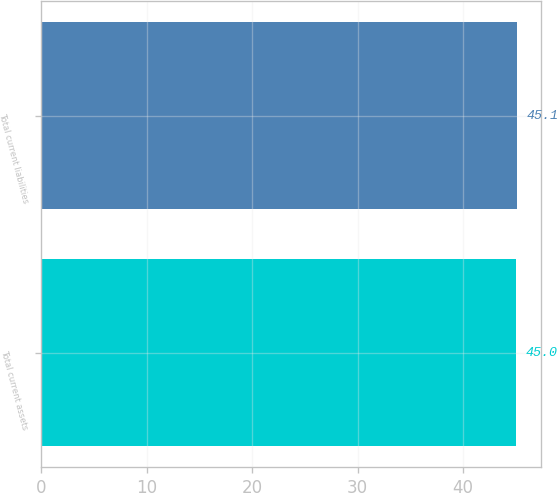<chart> <loc_0><loc_0><loc_500><loc_500><bar_chart><fcel>Total current assets<fcel>Total current liabilities<nl><fcel>45<fcel>45.1<nl></chart> 